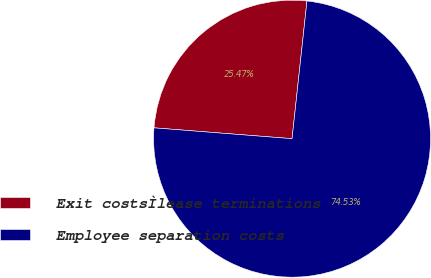Convert chart to OTSL. <chart><loc_0><loc_0><loc_500><loc_500><pie_chart><fcel>Exit costsÌlease terminations<fcel>Employee separation costs<nl><fcel>25.47%<fcel>74.53%<nl></chart> 